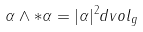Convert formula to latex. <formula><loc_0><loc_0><loc_500><loc_500>\alpha \wedge * \alpha = | \alpha | ^ { 2 } d v o l _ { g }</formula> 